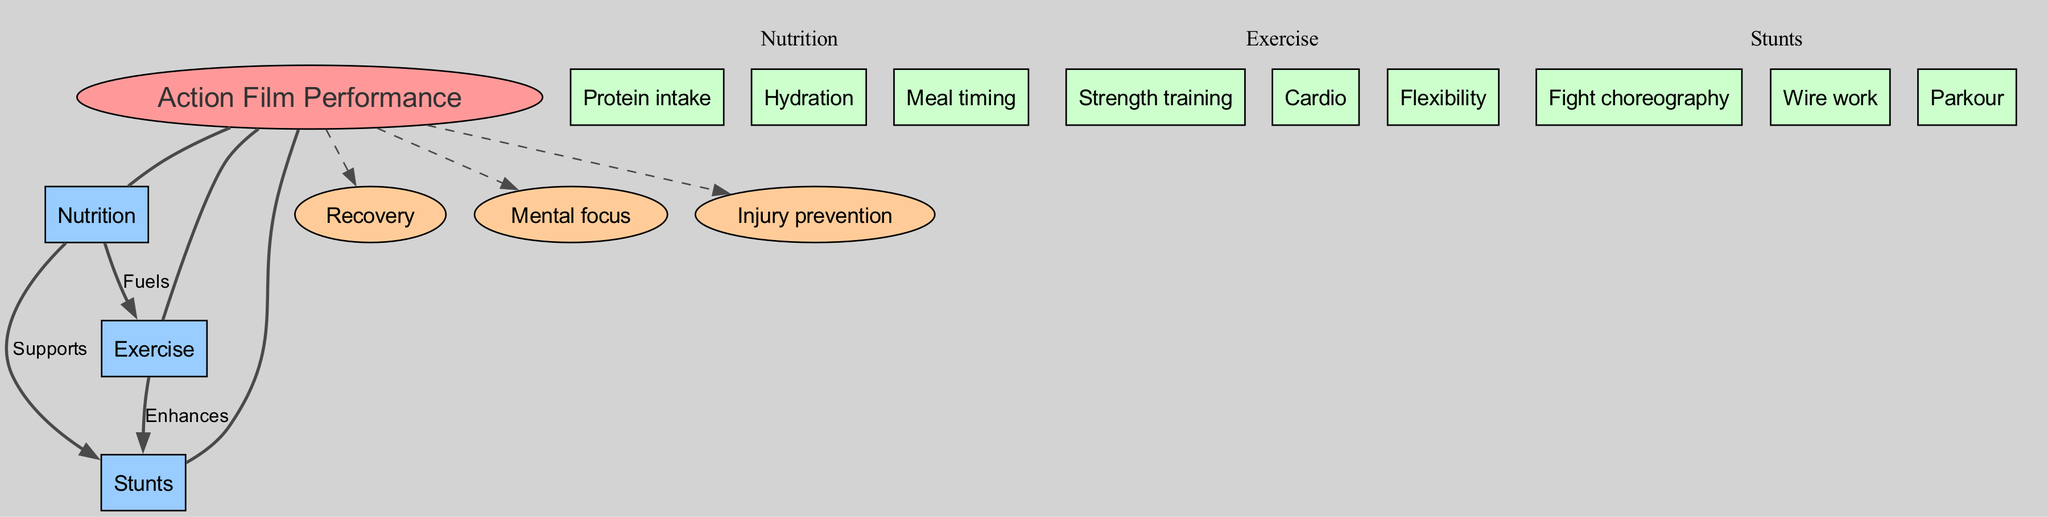What is the central concept of the diagram? The diagram clearly labels the central concept at the center, which is "Action Film Performance."
Answer: Action Film Performance How many main nodes are present in the diagram? The main nodes section contains three entries: "Nutrition," "Exercise," and "Stunts." Therefore, the total count of main nodes is three.
Answer: 3 What relationship does "Nutrition" have with "Exercise"? The diagram depicts a directed edge from the "Nutrition" node to the "Exercise" node with the label "Fuels," indicating that nutrition provides energy for exercise.
Answer: Fuels Which sub-node is linked to "Stunts" by "Nutrition"? The diagram shows a direct connection labeled "Supports" from "Nutrition" to "Stunts," meaning that one of the sub-nodes of nutrition supports the performance of stunts.
Answer: Supports What are the three types of exercise noted in the diagram? The exercise node has three sub-nodes listed as "Strength training," "Cardio," and "Flexibility," detailing the various forms of exercise.
Answer: Strength training, Cardio, Flexibility Which sub-node enhances "Stunts"? According to the diagram, "Exercise" has a direct connection labeled "Enhances" to "Stunts," which indicates that exercise improves or enhances the execution of stunts.
Answer: Enhances How many additional nodes are included in the diagram? The additional nodes section lists three entries: "Recovery," "Mental focus," and "Injury prevention," contributing to an understanding of overall action film performance.
Answer: 3 What type of node is labeled "Hydration"? The node "Hydration" is under "Nutrition," which is a sub-node, hence it is categorized as a sub-node of the main node "Nutrition."
Answer: Sub-node What does "Exercise" enhance in the context of the diagram? The diagram establishes a connection between "Exercise" and "Stunts" labeled "Enhances," indicating that exercise improves stunt performance.
Answer: Stunts 